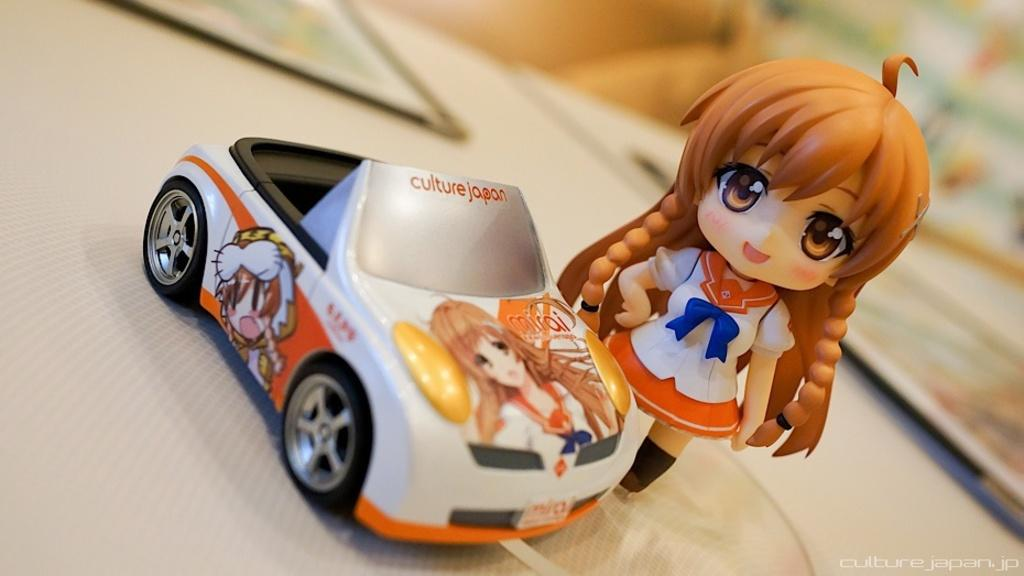What type of doll is in the image? There is a woman doll in the image. What other toy is present in the image? There is a car toy in the image. Where are the doll and the toy located? Both the doll and the toy are placed on a table. What type of behavior can be observed in the ducks in the image? There are no ducks present in the image, so no behavior can be observed. What type of car is shown in the image? The car in the image is a toy car, not a real car. 